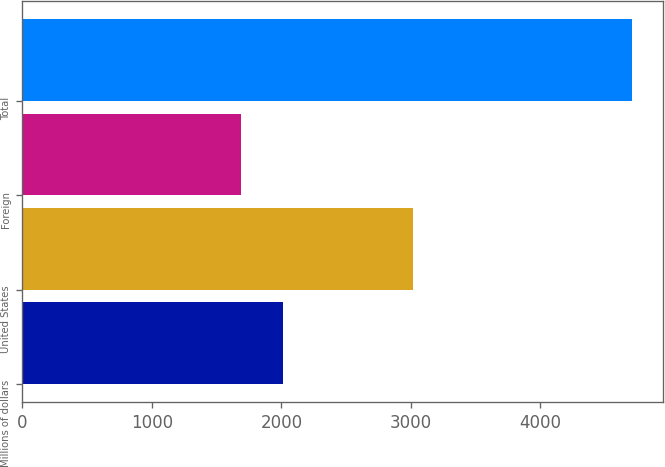Convert chart to OTSL. <chart><loc_0><loc_0><loc_500><loc_500><bar_chart><fcel>Millions of dollars<fcel>United States<fcel>Foreign<fcel>Total<nl><fcel>2014<fcel>3020<fcel>1692<fcel>4712<nl></chart> 